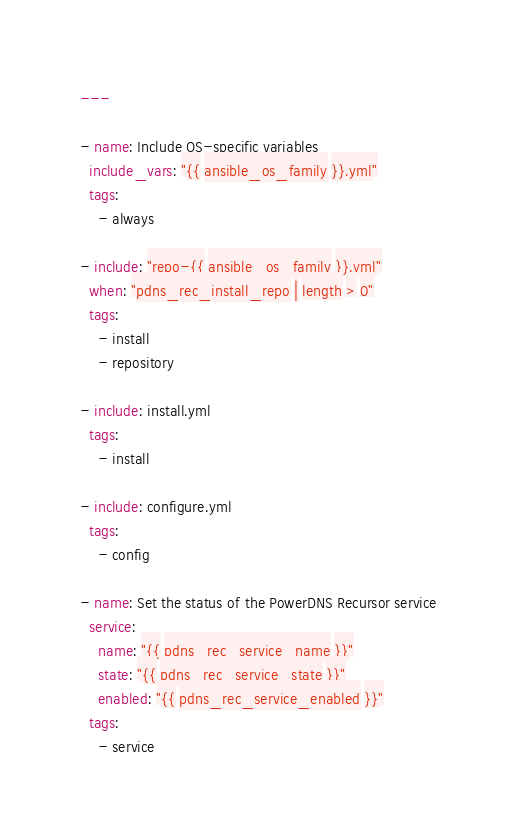<code> <loc_0><loc_0><loc_500><loc_500><_YAML_>---

- name: Include OS-specific variables
  include_vars: "{{ ansible_os_family }}.yml"
  tags:
    - always

- include: "repo-{{ ansible_os_family }}.yml"
  when: "pdns_rec_install_repo | length > 0"
  tags:
    - install
    - repository

- include: install.yml
  tags:
    - install

- include: configure.yml
  tags:
    - config

- name: Set the status of the PowerDNS Recursor service
  service:
    name: "{{ pdns_rec_service_name }}"
    state: "{{ pdns_rec_service_state }}"
    enabled: "{{ pdns_rec_service_enabled }}"
  tags:
    - service
</code> 